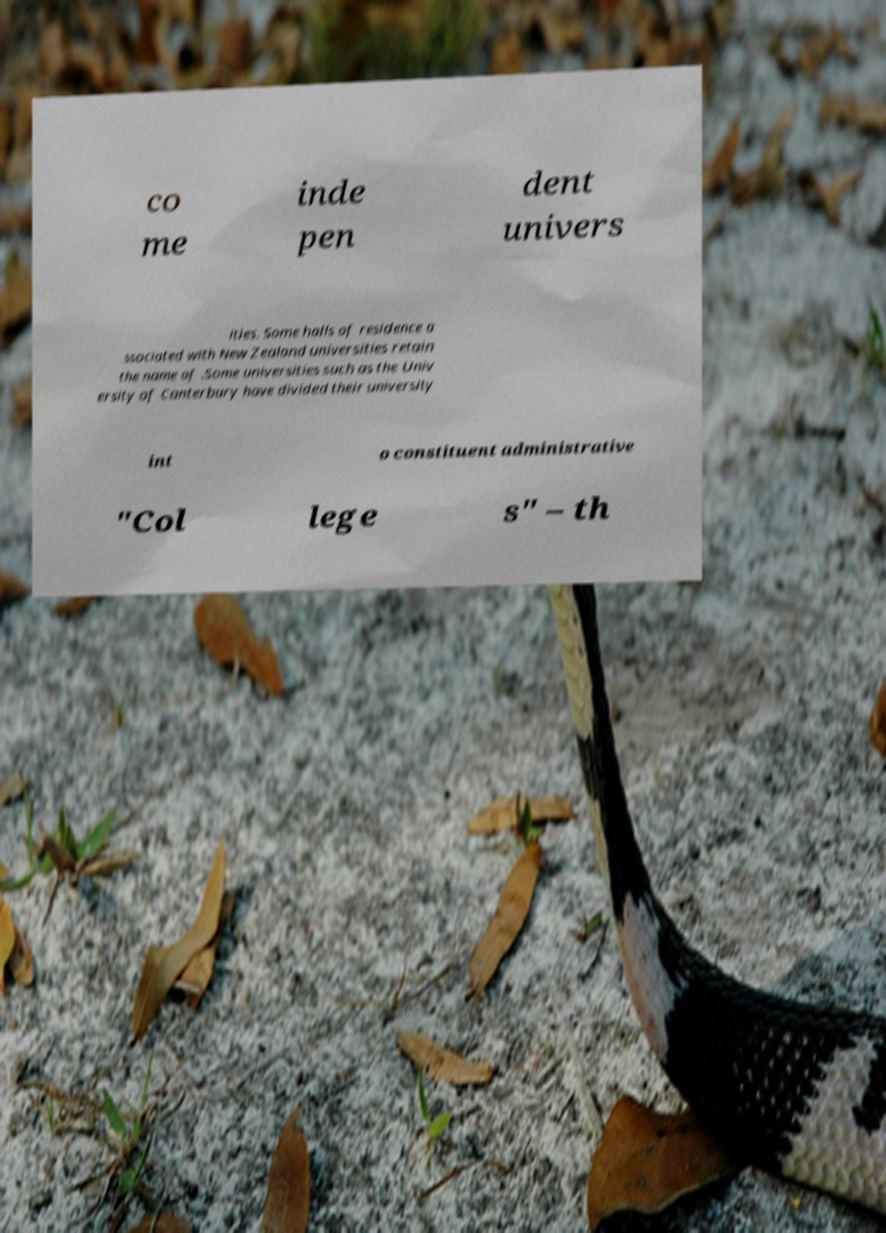Could you extract and type out the text from this image? co me inde pen dent univers ities. Some halls of residence a ssociated with New Zealand universities retain the name of .Some universities such as the Univ ersity of Canterbury have divided their university int o constituent administrative "Col lege s" – th 